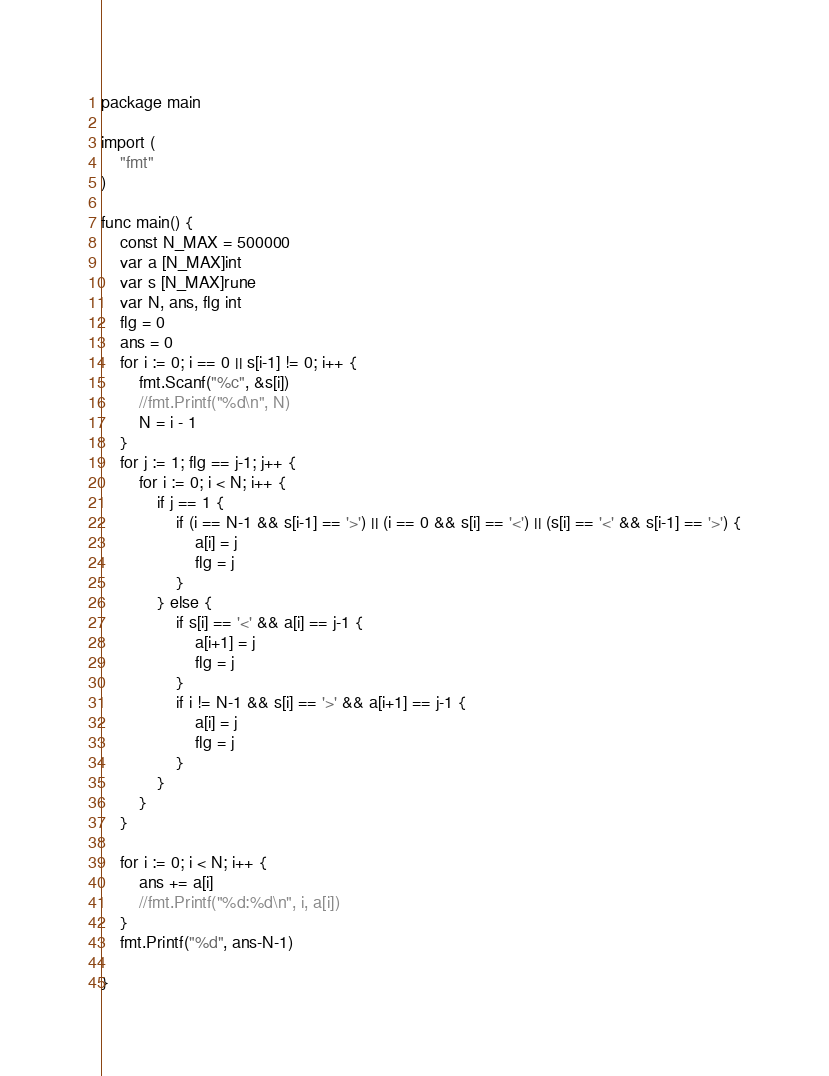Convert code to text. <code><loc_0><loc_0><loc_500><loc_500><_Go_>package main

import (
	"fmt"
)

func main() {
	const N_MAX = 500000
	var a [N_MAX]int
	var s [N_MAX]rune
	var N, ans, flg int
	flg = 0
	ans = 0
	for i := 0; i == 0 || s[i-1] != 0; i++ {
		fmt.Scanf("%c", &s[i])
		//fmt.Printf("%d\n", N)
		N = i - 1
	}
	for j := 1; flg == j-1; j++ {
		for i := 0; i < N; i++ {
			if j == 1 {
				if (i == N-1 && s[i-1] == '>') || (i == 0 && s[i] == '<') || (s[i] == '<' && s[i-1] == '>') {
					a[i] = j
					flg = j
				}
			} else {
				if s[i] == '<' && a[i] == j-1 {
					a[i+1] = j
					flg = j
				}
				if i != N-1 && s[i] == '>' && a[i+1] == j-1 {
					a[i] = j
					flg = j
				}
			}
		}
	}

	for i := 0; i < N; i++ {
		ans += a[i]
		//fmt.Printf("%d:%d\n", i, a[i])
	}
	fmt.Printf("%d", ans-N-1)

}
</code> 